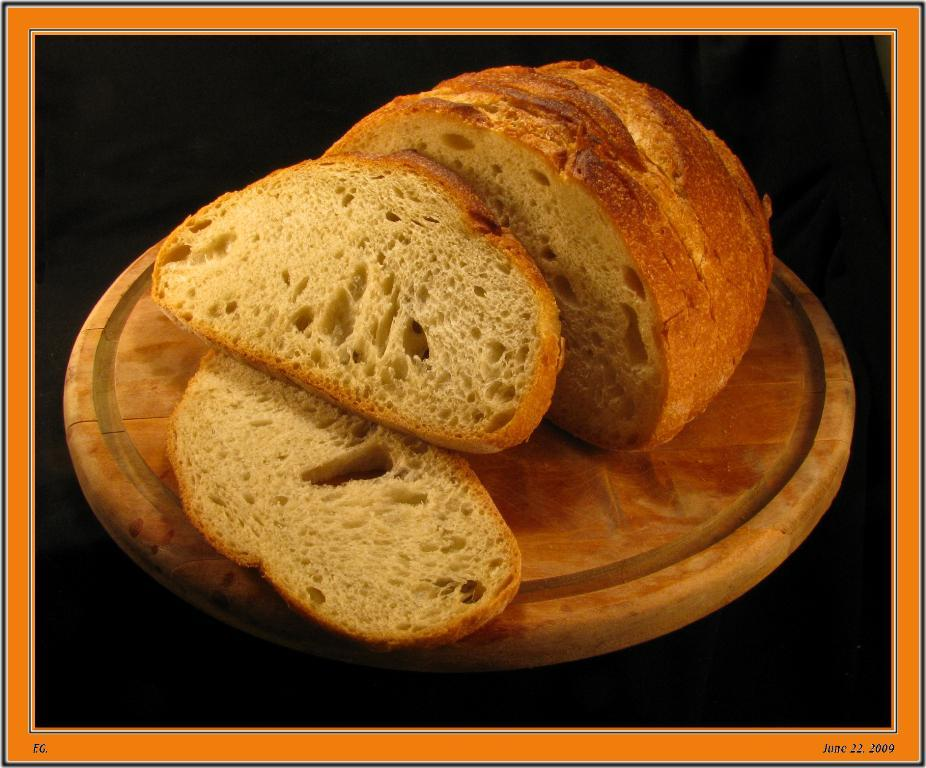What type of food can be seen in the image? There are slices of bread in the image. Where are the slices of bread placed? The slices of bread are placed on a wooden board. What type of powder can be seen covering the bread in the image? There is no powder visible on the bread in the image; it is simply slices of bread placed on a wooden board. 